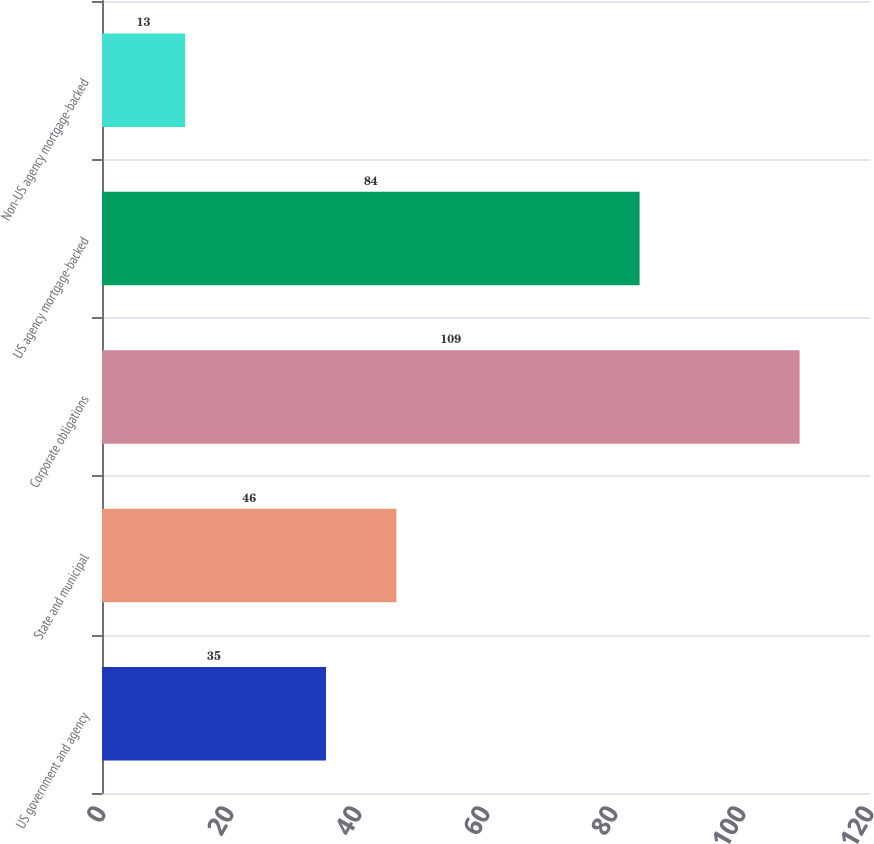Convert chart to OTSL. <chart><loc_0><loc_0><loc_500><loc_500><bar_chart><fcel>US government and agency<fcel>State and municipal<fcel>Corporate obligations<fcel>US agency mortgage-backed<fcel>Non-US agency mortgage-backed<nl><fcel>35<fcel>46<fcel>109<fcel>84<fcel>13<nl></chart> 